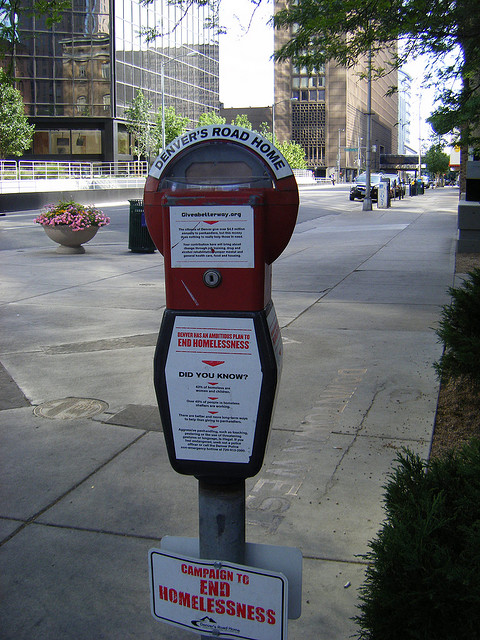Extract all visible text content from this image. DENVER'S ROAD HOME HOMELESSNESS HOMELESSNESS END TO CAMPAIGN Chinabetterway.org END KNOW YOU DID 